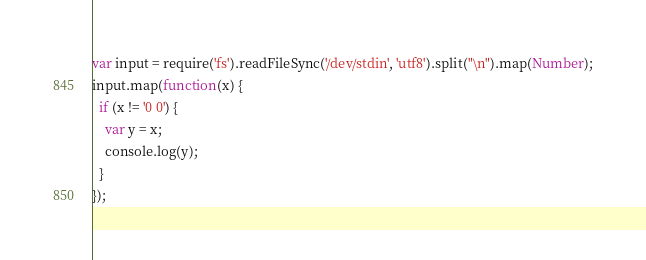Convert code to text. <code><loc_0><loc_0><loc_500><loc_500><_JavaScript_>var input = require('fs').readFileSync('/dev/stdin', 'utf8').split("\n").map(Number);
input.map(function(x) {
  if (x != '0 0') {
    var y = x;
    console.log(y);
  }
});</code> 